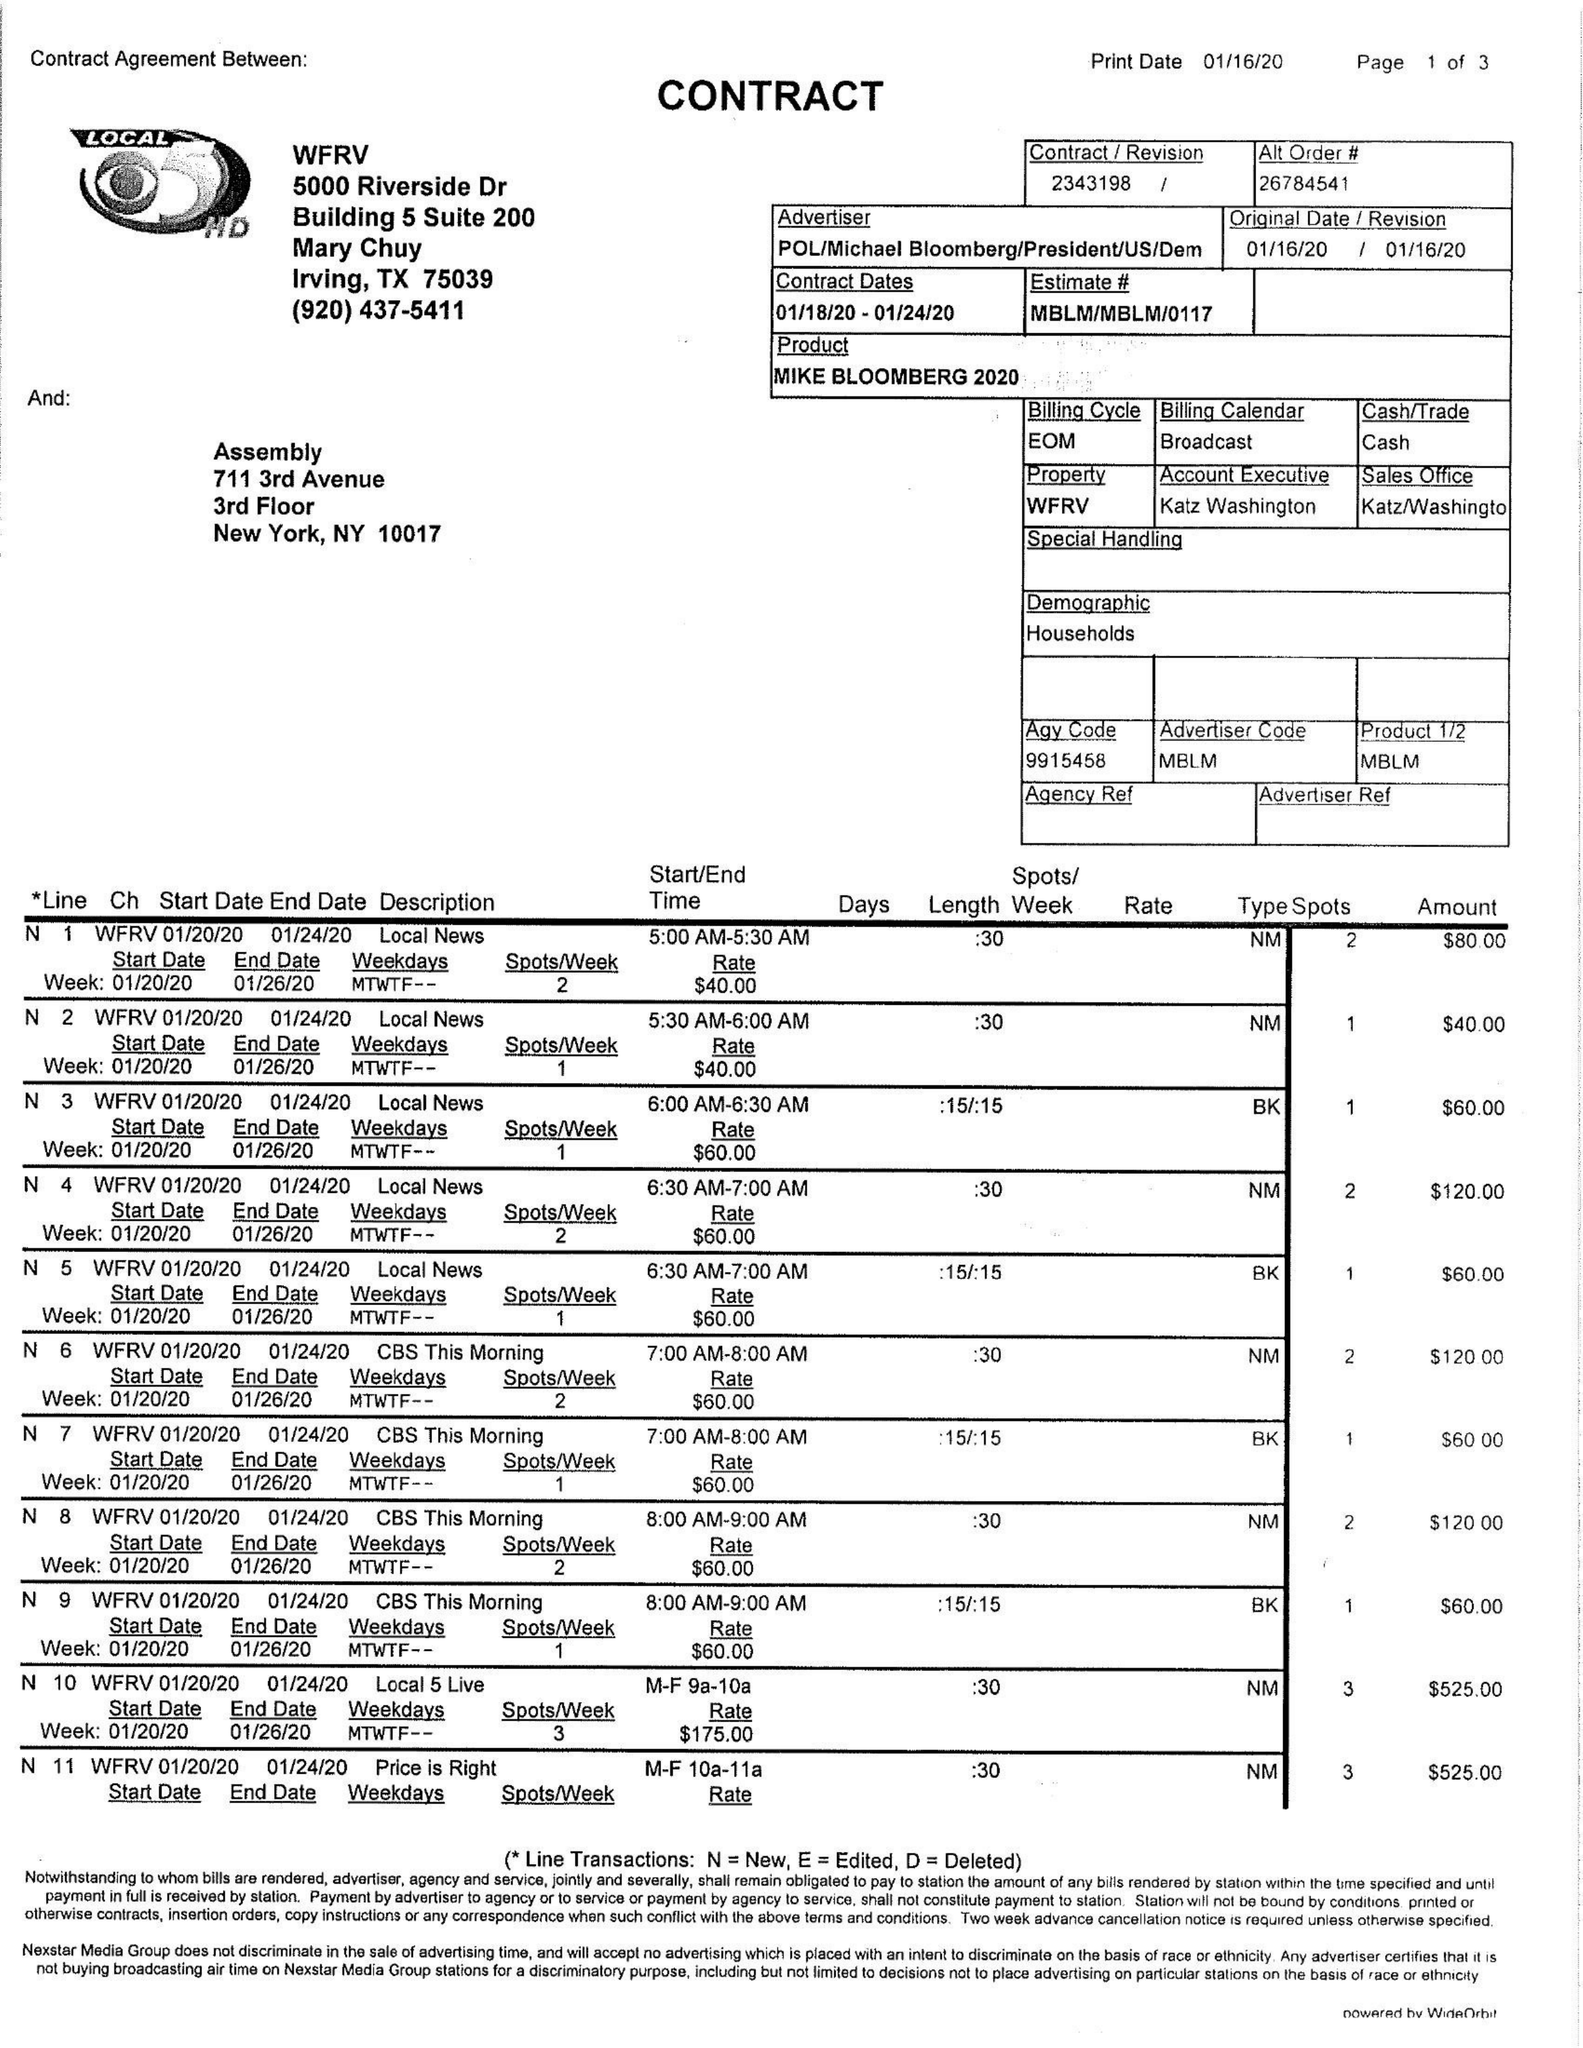What is the value for the contract_num?
Answer the question using a single word or phrase. 2343198 